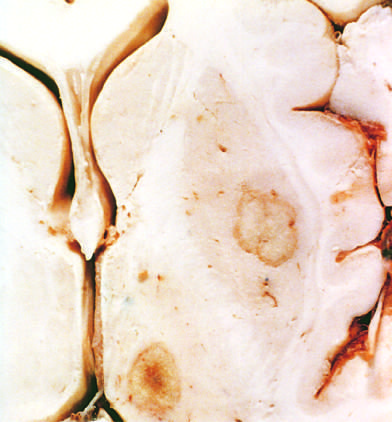re the upper parts of both lungs present in the putamen and thalamus?
Answer the question using a single word or phrase. No 